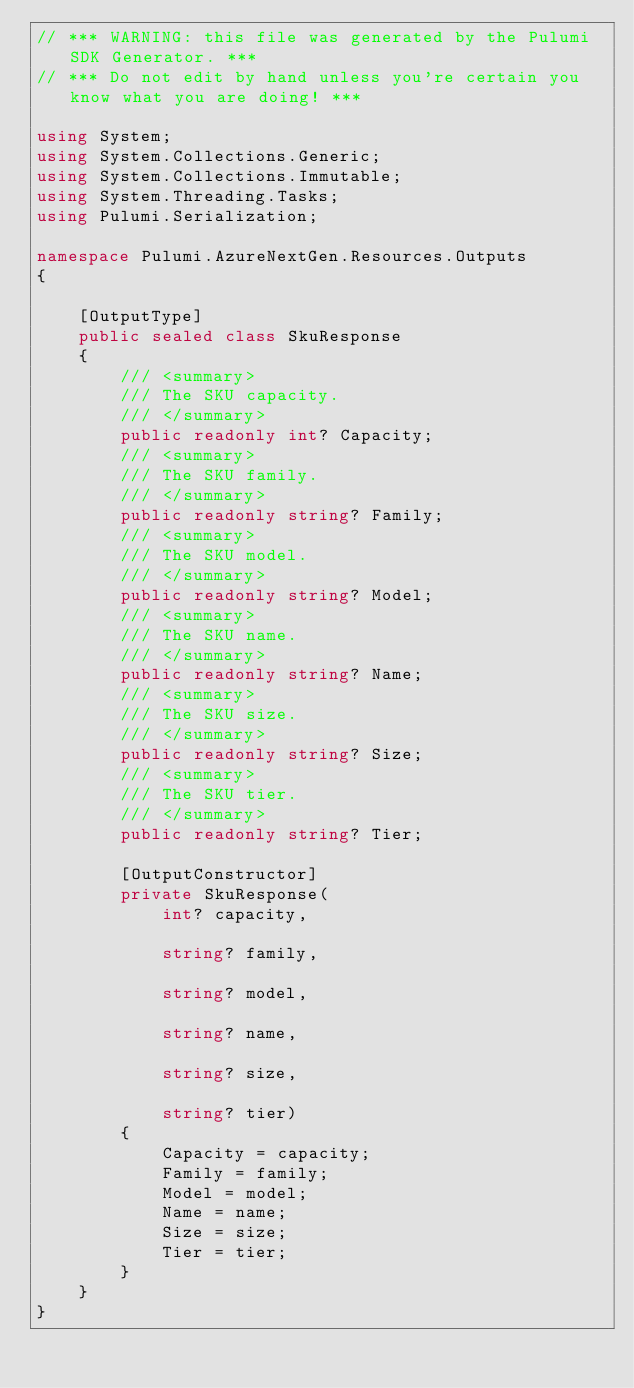<code> <loc_0><loc_0><loc_500><loc_500><_C#_>// *** WARNING: this file was generated by the Pulumi SDK Generator. ***
// *** Do not edit by hand unless you're certain you know what you are doing! ***

using System;
using System.Collections.Generic;
using System.Collections.Immutable;
using System.Threading.Tasks;
using Pulumi.Serialization;

namespace Pulumi.AzureNextGen.Resources.Outputs
{

    [OutputType]
    public sealed class SkuResponse
    {
        /// <summary>
        /// The SKU capacity.
        /// </summary>
        public readonly int? Capacity;
        /// <summary>
        /// The SKU family.
        /// </summary>
        public readonly string? Family;
        /// <summary>
        /// The SKU model.
        /// </summary>
        public readonly string? Model;
        /// <summary>
        /// The SKU name.
        /// </summary>
        public readonly string? Name;
        /// <summary>
        /// The SKU size.
        /// </summary>
        public readonly string? Size;
        /// <summary>
        /// The SKU tier.
        /// </summary>
        public readonly string? Tier;

        [OutputConstructor]
        private SkuResponse(
            int? capacity,

            string? family,

            string? model,

            string? name,

            string? size,

            string? tier)
        {
            Capacity = capacity;
            Family = family;
            Model = model;
            Name = name;
            Size = size;
            Tier = tier;
        }
    }
}
</code> 